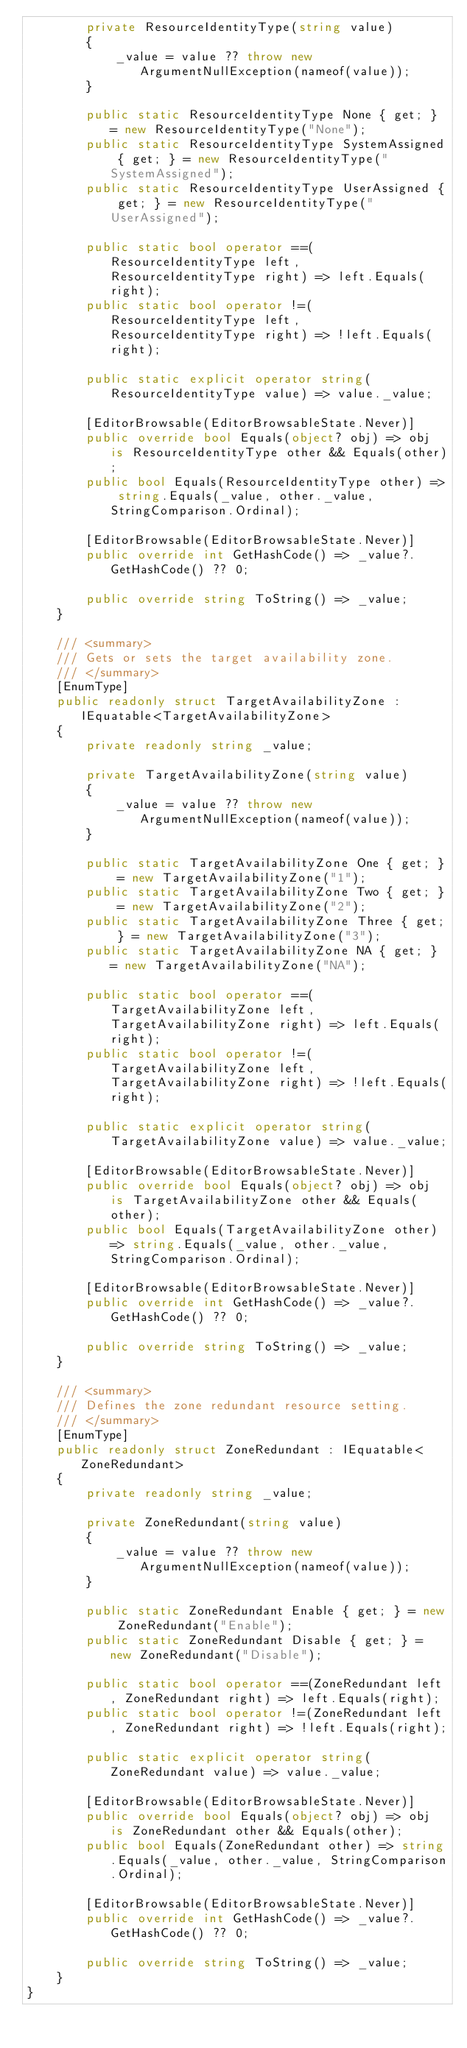<code> <loc_0><loc_0><loc_500><loc_500><_C#_>        private ResourceIdentityType(string value)
        {
            _value = value ?? throw new ArgumentNullException(nameof(value));
        }

        public static ResourceIdentityType None { get; } = new ResourceIdentityType("None");
        public static ResourceIdentityType SystemAssigned { get; } = new ResourceIdentityType("SystemAssigned");
        public static ResourceIdentityType UserAssigned { get; } = new ResourceIdentityType("UserAssigned");

        public static bool operator ==(ResourceIdentityType left, ResourceIdentityType right) => left.Equals(right);
        public static bool operator !=(ResourceIdentityType left, ResourceIdentityType right) => !left.Equals(right);

        public static explicit operator string(ResourceIdentityType value) => value._value;

        [EditorBrowsable(EditorBrowsableState.Never)]
        public override bool Equals(object? obj) => obj is ResourceIdentityType other && Equals(other);
        public bool Equals(ResourceIdentityType other) => string.Equals(_value, other._value, StringComparison.Ordinal);

        [EditorBrowsable(EditorBrowsableState.Never)]
        public override int GetHashCode() => _value?.GetHashCode() ?? 0;

        public override string ToString() => _value;
    }

    /// <summary>
    /// Gets or sets the target availability zone.
    /// </summary>
    [EnumType]
    public readonly struct TargetAvailabilityZone : IEquatable<TargetAvailabilityZone>
    {
        private readonly string _value;

        private TargetAvailabilityZone(string value)
        {
            _value = value ?? throw new ArgumentNullException(nameof(value));
        }

        public static TargetAvailabilityZone One { get; } = new TargetAvailabilityZone("1");
        public static TargetAvailabilityZone Two { get; } = new TargetAvailabilityZone("2");
        public static TargetAvailabilityZone Three { get; } = new TargetAvailabilityZone("3");
        public static TargetAvailabilityZone NA { get; } = new TargetAvailabilityZone("NA");

        public static bool operator ==(TargetAvailabilityZone left, TargetAvailabilityZone right) => left.Equals(right);
        public static bool operator !=(TargetAvailabilityZone left, TargetAvailabilityZone right) => !left.Equals(right);

        public static explicit operator string(TargetAvailabilityZone value) => value._value;

        [EditorBrowsable(EditorBrowsableState.Never)]
        public override bool Equals(object? obj) => obj is TargetAvailabilityZone other && Equals(other);
        public bool Equals(TargetAvailabilityZone other) => string.Equals(_value, other._value, StringComparison.Ordinal);

        [EditorBrowsable(EditorBrowsableState.Never)]
        public override int GetHashCode() => _value?.GetHashCode() ?? 0;

        public override string ToString() => _value;
    }

    /// <summary>
    /// Defines the zone redundant resource setting.
    /// </summary>
    [EnumType]
    public readonly struct ZoneRedundant : IEquatable<ZoneRedundant>
    {
        private readonly string _value;

        private ZoneRedundant(string value)
        {
            _value = value ?? throw new ArgumentNullException(nameof(value));
        }

        public static ZoneRedundant Enable { get; } = new ZoneRedundant("Enable");
        public static ZoneRedundant Disable { get; } = new ZoneRedundant("Disable");

        public static bool operator ==(ZoneRedundant left, ZoneRedundant right) => left.Equals(right);
        public static bool operator !=(ZoneRedundant left, ZoneRedundant right) => !left.Equals(right);

        public static explicit operator string(ZoneRedundant value) => value._value;

        [EditorBrowsable(EditorBrowsableState.Never)]
        public override bool Equals(object? obj) => obj is ZoneRedundant other && Equals(other);
        public bool Equals(ZoneRedundant other) => string.Equals(_value, other._value, StringComparison.Ordinal);

        [EditorBrowsable(EditorBrowsableState.Never)]
        public override int GetHashCode() => _value?.GetHashCode() ?? 0;

        public override string ToString() => _value;
    }
}
</code> 